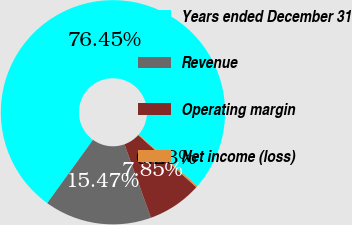Convert chart to OTSL. <chart><loc_0><loc_0><loc_500><loc_500><pie_chart><fcel>Years ended December 31<fcel>Revenue<fcel>Operating margin<fcel>Net income (loss)<nl><fcel>76.45%<fcel>15.47%<fcel>7.85%<fcel>0.23%<nl></chart> 